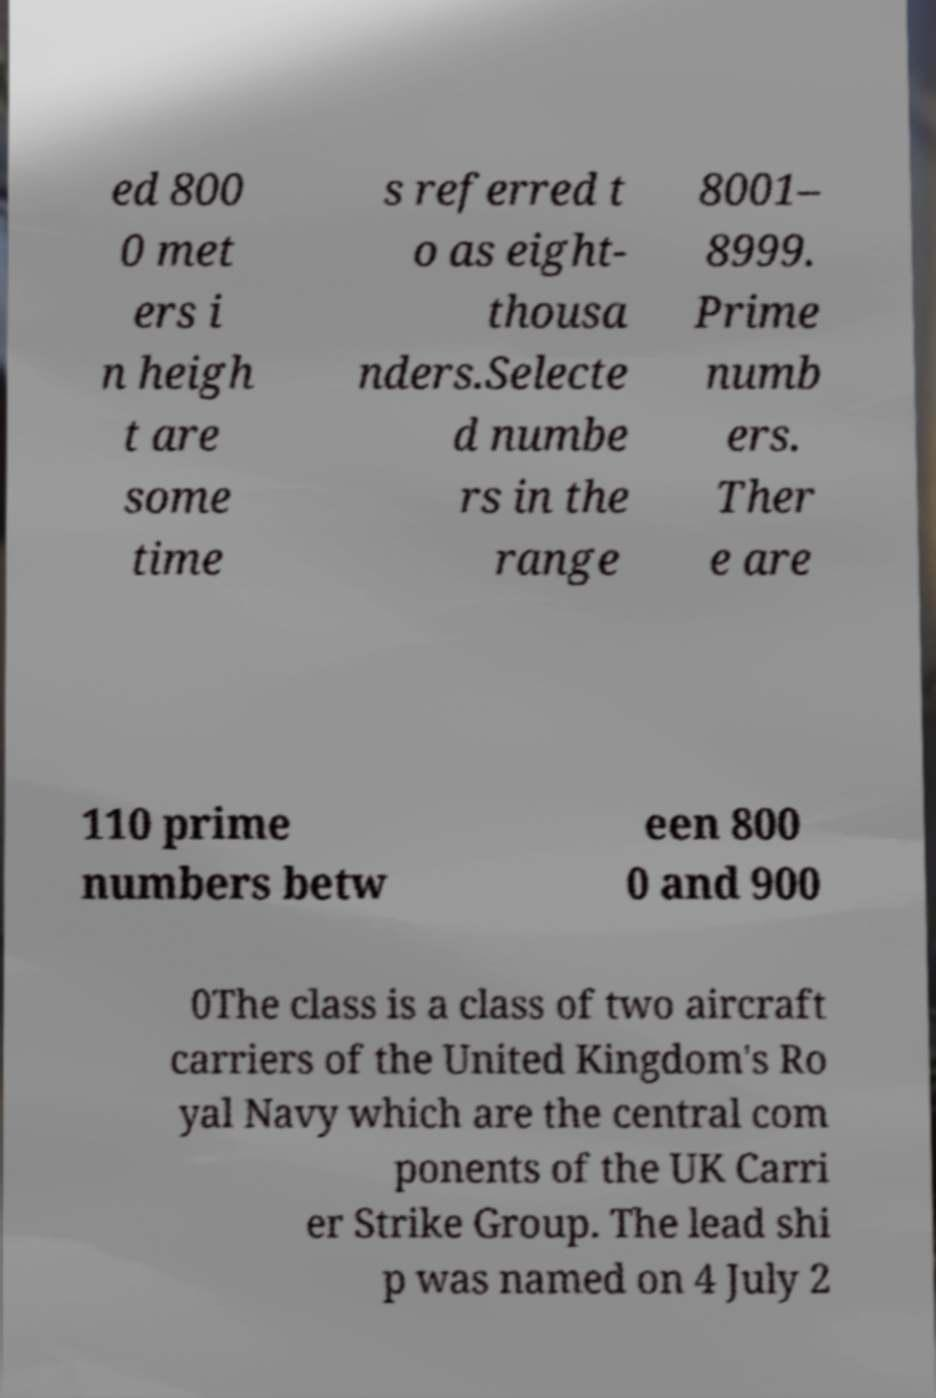Could you assist in decoding the text presented in this image and type it out clearly? ed 800 0 met ers i n heigh t are some time s referred t o as eight- thousa nders.Selecte d numbe rs in the range 8001– 8999. Prime numb ers. Ther e are 110 prime numbers betw een 800 0 and 900 0The class is a class of two aircraft carriers of the United Kingdom's Ro yal Navy which are the central com ponents of the UK Carri er Strike Group. The lead shi p was named on 4 July 2 